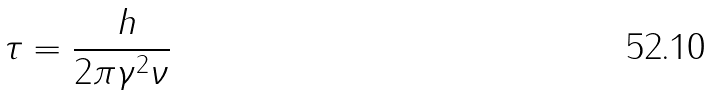Convert formula to latex. <formula><loc_0><loc_0><loc_500><loc_500>\tau = \frac { \ h } { 2 \pi \gamma ^ { 2 } \nu }</formula> 